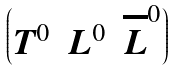<formula> <loc_0><loc_0><loc_500><loc_500>\begin{pmatrix} T ^ { 0 } & L ^ { 0 } & \overline { L } ^ { 0 } \end{pmatrix}</formula> 